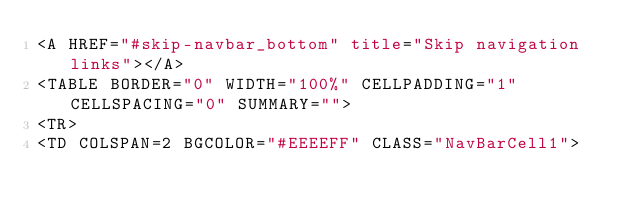Convert code to text. <code><loc_0><loc_0><loc_500><loc_500><_HTML_><A HREF="#skip-navbar_bottom" title="Skip navigation links"></A>
<TABLE BORDER="0" WIDTH="100%" CELLPADDING="1" CELLSPACING="0" SUMMARY="">
<TR>
<TD COLSPAN=2 BGCOLOR="#EEEEFF" CLASS="NavBarCell1"></code> 